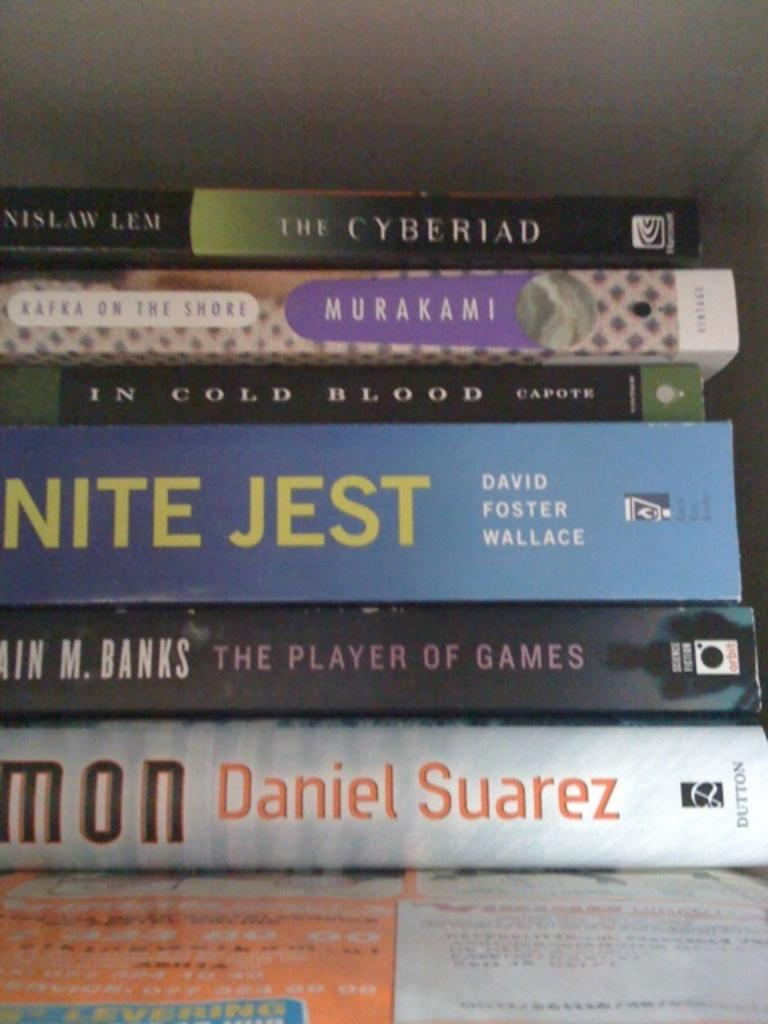<image>
Provide a brief description of the given image. A stack of books contains a work by David Foster Wallace. 